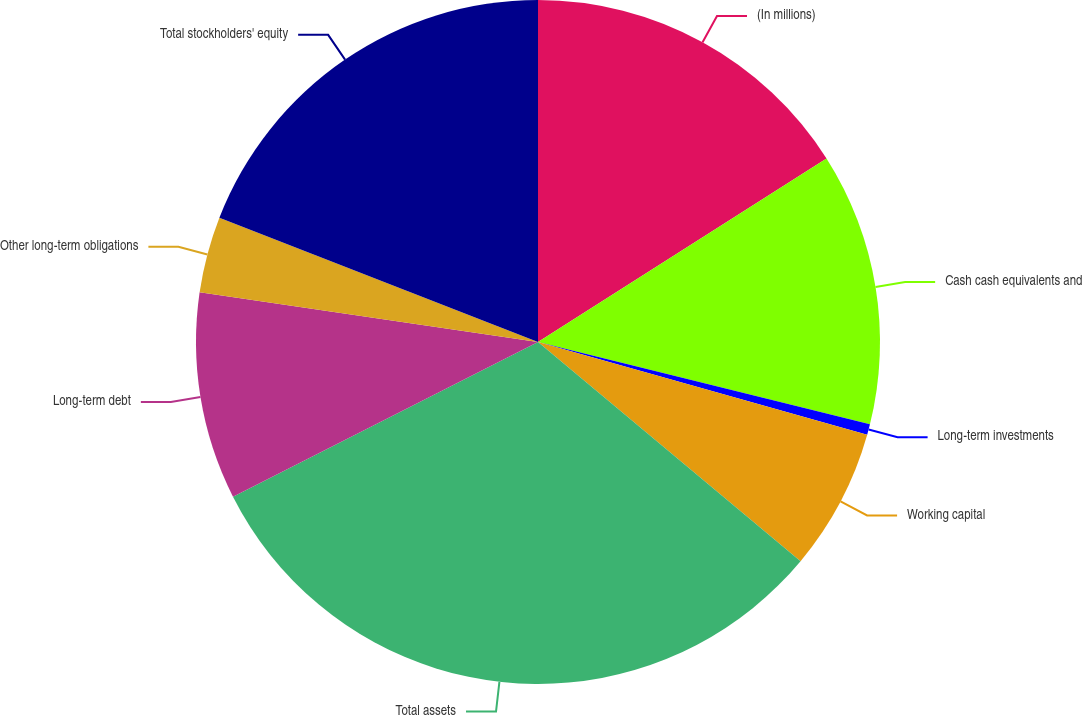<chart> <loc_0><loc_0><loc_500><loc_500><pie_chart><fcel>(In millions)<fcel>Cash cash equivalents and<fcel>Long-term investments<fcel>Working capital<fcel>Total assets<fcel>Long-term debt<fcel>Other long-term obligations<fcel>Total stockholders' equity<nl><fcel>15.98%<fcel>12.89%<fcel>0.5%<fcel>6.7%<fcel>31.46%<fcel>9.79%<fcel>3.6%<fcel>19.08%<nl></chart> 